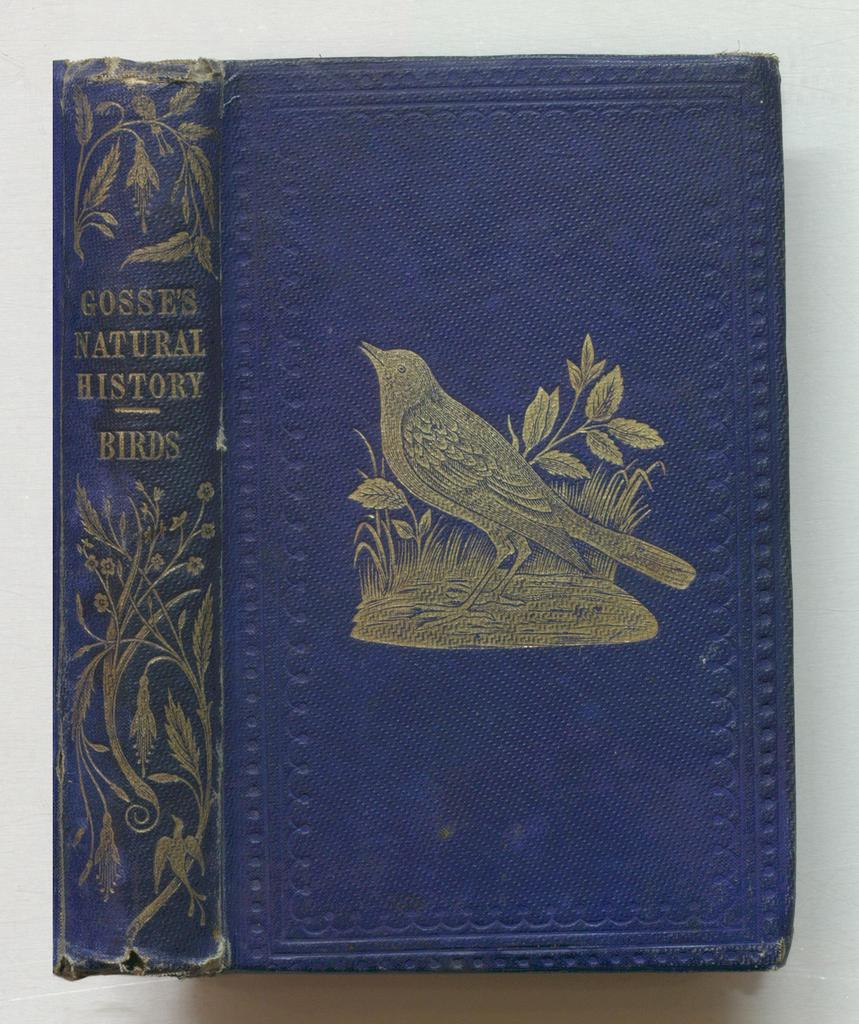<image>
Offer a succinct explanation of the picture presented. A blue book with a bird on the cover is about the natural history of birds. 